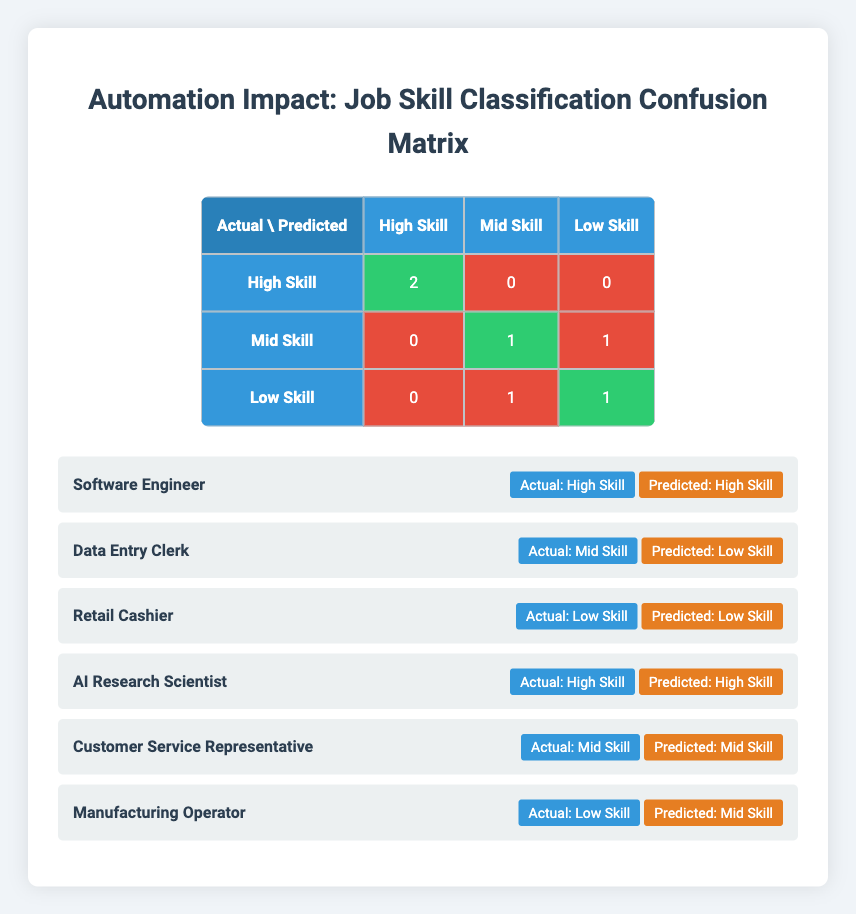What is the total number of jobs classified as "High Skill"? From the confusion matrix, we see that there are 2 jobs that are classified as "High Skill" (both predicted correctly), which can be found in the row for "High Skill" under the actual skill class.
Answer: 2 How many jobs were misclassified as "Low Skill"? From the confusion matrix, the number of misclassified jobs predicted as "Low Skill" is 1. This comes from the mid-skill job "Data Entry Clerk" incorrectly predicted as "Low Skill".
Answer: 1 What is the number of jobs correctly classified as "Mid Skill"? Referring to the confusion matrix, we find that 1 job (Customer Service Representative) was correctly classified as "Mid Skill", which can be seen in the corresponding cell of the matrix.
Answer: 1 Is there any job that was misclassified as "High Skill"? Checking the confusion matrix, there are no instances where a job was incorrectly classified as "High Skill". All jobs that should be high skill were predicted as such.
Answer: No What is the proportion of correctly classified jobs among all jobs listed? There are a total of 6 jobs (2 correct in High Skill, 1 correct in Mid Skill, and 1 correct in Low Skill). The total correct classifications are 4, so the proportion is 4/6, resulting in approximately 66.67%.
Answer: 66.67 percent How many jobs were correctly predicted as "Low Skill"? By looking at the confusion matrix, we observe that 1 job ("Retail Cashier") was correctly identified as "Low Skill". This can be found in the "Low Skill" row and the "Low Skill" column.
Answer: 1 What is the total count of jobs in each skill category (High, Mid, Low)? By counting from the confusion matrix and job roles data points, the total for each category is: High Skill: 2, Mid Skill: 2, Low Skill: 2. This is derived from the actual labels.
Answer: High Skill: 2, Mid Skill: 2, Low Skill: 2 Was the "Data Entry Clerk" job predicted correctly? From the job list, the "Data Entry Clerk" was actually labeled as "Mid Skill" but was incorrectly predicted as "Low Skill". This indicates a misclassification.
Answer: No How many total job roles are there that were predicted as "Mid Skill"? Looking at the predicted labels, we can find that there are 3 jobs predicted as "Mid Skill" (Data Entry Clerk, Customer Service Representative, Manufacturing Operator).
Answer: 3 